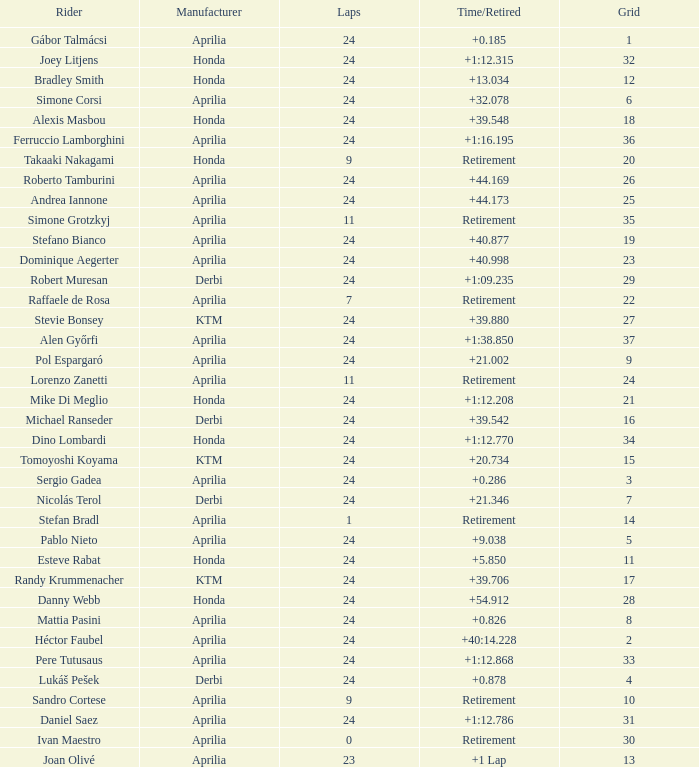How many grids have more than 24 laps with a time/retired of +1:12.208? None. 